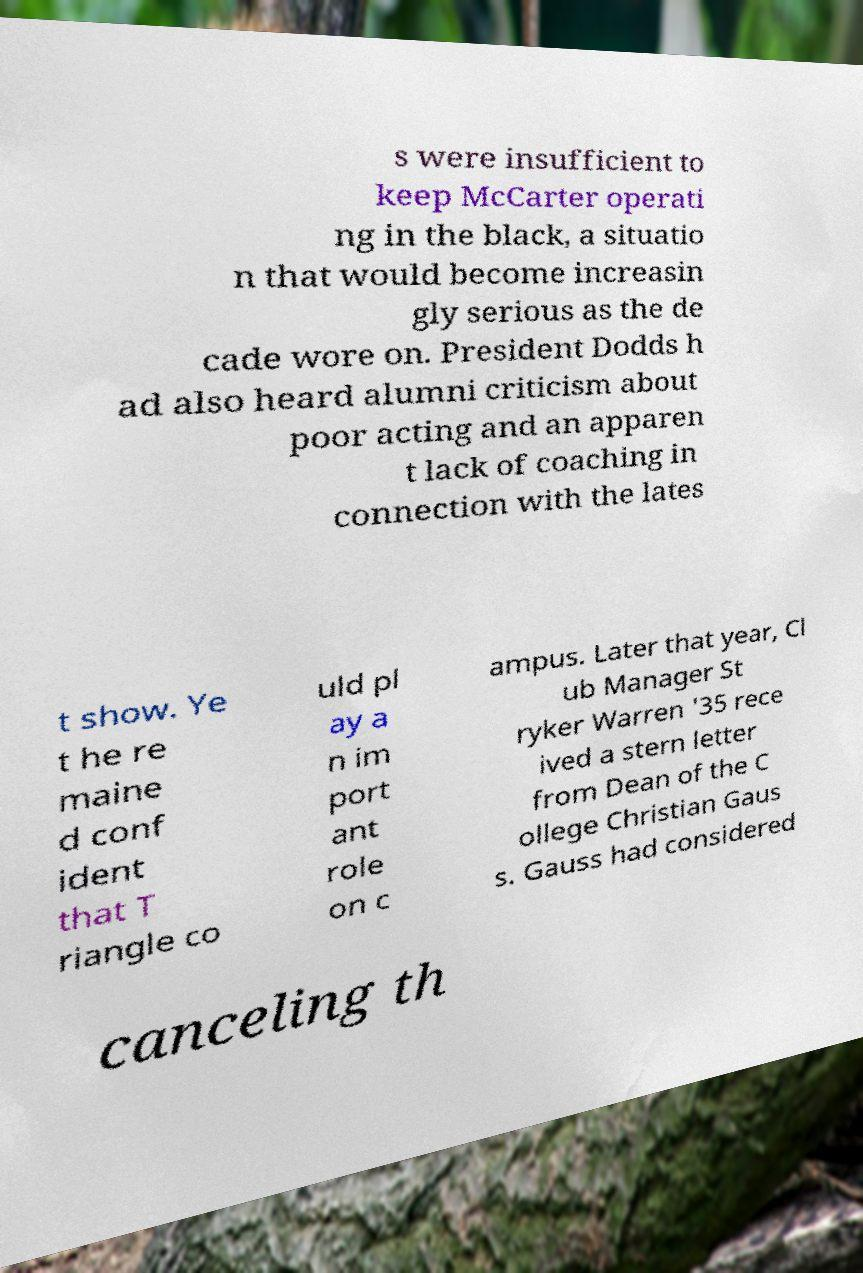For documentation purposes, I need the text within this image transcribed. Could you provide that? s were insufficient to keep McCarter operati ng in the black, a situatio n that would become increasin gly serious as the de cade wore on. President Dodds h ad also heard alumni criticism about poor acting and an apparen t lack of coaching in connection with the lates t show. Ye t he re maine d conf ident that T riangle co uld pl ay a n im port ant role on c ampus. Later that year, Cl ub Manager St ryker Warren '35 rece ived a stern letter from Dean of the C ollege Christian Gaus s. Gauss had considered canceling th 